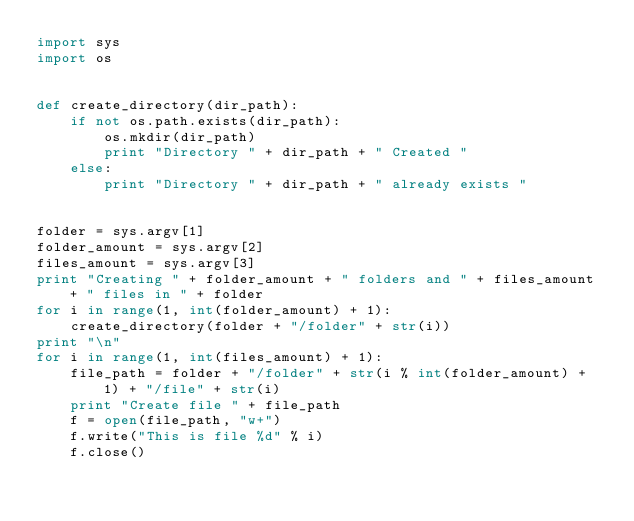Convert code to text. <code><loc_0><loc_0><loc_500><loc_500><_Python_>import sys
import os


def create_directory(dir_path):
    if not os.path.exists(dir_path):
        os.mkdir(dir_path)
        print "Directory " + dir_path + " Created "
    else:
        print "Directory " + dir_path + " already exists "


folder = sys.argv[1]
folder_amount = sys.argv[2]
files_amount = sys.argv[3]
print "Creating " + folder_amount + " folders and " + files_amount + " files in " + folder
for i in range(1, int(folder_amount) + 1):
    create_directory(folder + "/folder" + str(i))
print "\n"
for i in range(1, int(files_amount) + 1):
    file_path = folder + "/folder" + str(i % int(folder_amount) + 1) + "/file" + str(i)
    print "Create file " + file_path
    f = open(file_path, "w+")
    f.write("This is file %d" % i)
    f.close()
</code> 